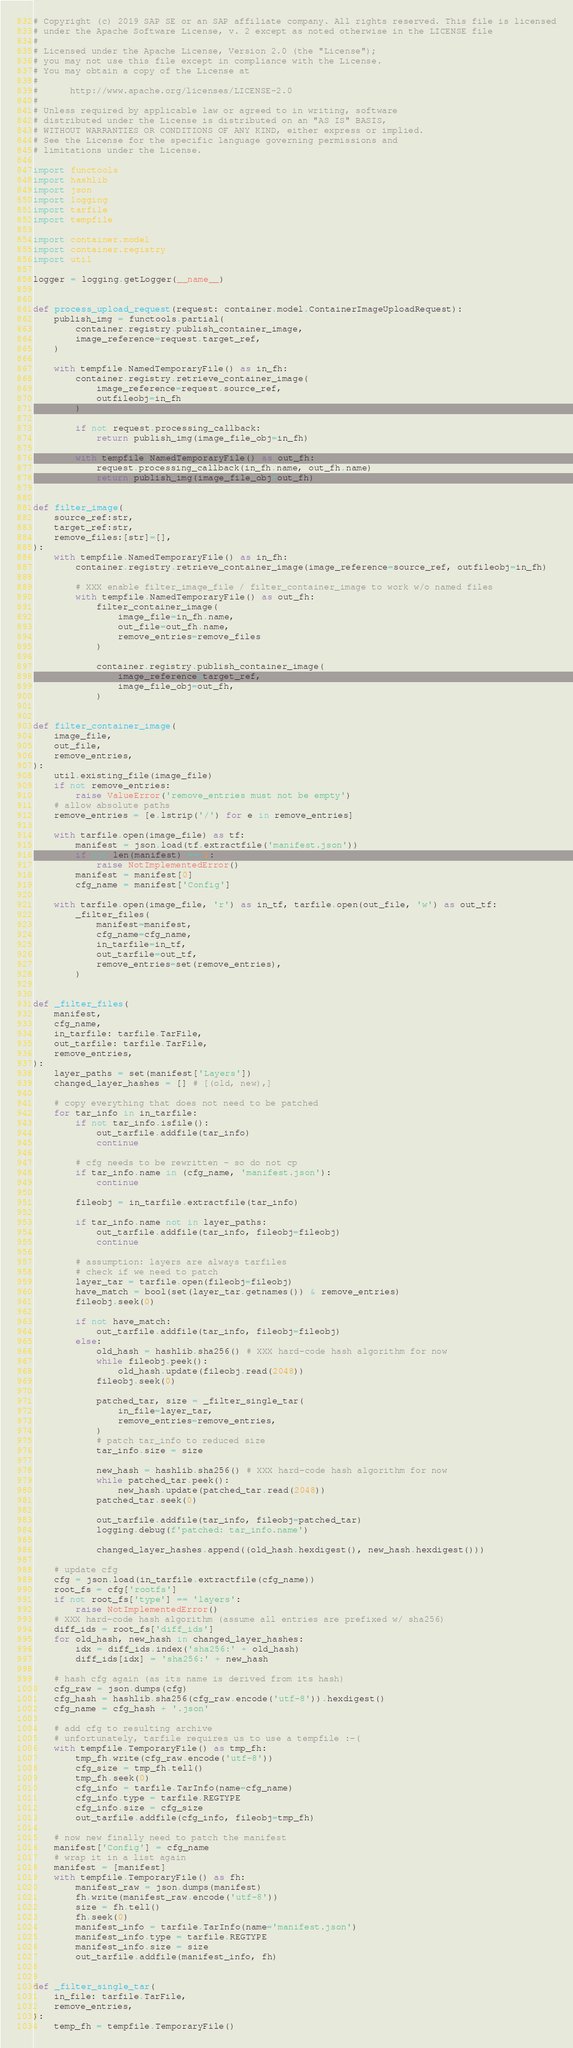<code> <loc_0><loc_0><loc_500><loc_500><_Python_># Copyright (c) 2019 SAP SE or an SAP affiliate company. All rights reserved. This file is licensed
# under the Apache Software License, v. 2 except as noted otherwise in the LICENSE file
#
# Licensed under the Apache License, Version 2.0 (the "License");
# you may not use this file except in compliance with the License.
# You may obtain a copy of the License at
#
#      http://www.apache.org/licenses/LICENSE-2.0
#
# Unless required by applicable law or agreed to in writing, software
# distributed under the License is distributed on an "AS IS" BASIS,
# WITHOUT WARRANTIES OR CONDITIONS OF ANY KIND, either express or implied.
# See the License for the specific language governing permissions and
# limitations under the License.

import functools
import hashlib
import json
import logging
import tarfile
import tempfile

import container.model
import container.registry
import util

logger = logging.getLogger(__name__)


def process_upload_request(request: container.model.ContainerImageUploadRequest):
    publish_img = functools.partial(
        container.registry.publish_container_image,
        image_reference=request.target_ref,
    )

    with tempfile.NamedTemporaryFile() as in_fh:
        container.registry.retrieve_container_image(
            image_reference=request.source_ref,
            outfileobj=in_fh
        )

        if not request.processing_callback:
            return publish_img(image_file_obj=in_fh)

        with tempfile.NamedTemporaryFile() as out_fh:
            request.processing_callback(in_fh.name, out_fh.name)
            return publish_img(image_file_obj=out_fh)


def filter_image(
    source_ref:str,
    target_ref:str,
    remove_files:[str]=[],
):
    with tempfile.NamedTemporaryFile() as in_fh:
        container.registry.retrieve_container_image(image_reference=source_ref, outfileobj=in_fh)

        # XXX enable filter_image_file / filter_container_image to work w/o named files
        with tempfile.NamedTemporaryFile() as out_fh:
            filter_container_image(
                image_file=in_fh.name,
                out_file=out_fh.name,
                remove_entries=remove_files
            )

            container.registry.publish_container_image(
                image_reference=target_ref,
                image_file_obj=out_fh,
            )


def filter_container_image(
    image_file,
    out_file,
    remove_entries,
):
    util.existing_file(image_file)
    if not remove_entries:
        raise ValueError('remove_entries must not be empty')
    # allow absolute paths
    remove_entries = [e.lstrip('/') for e in remove_entries]

    with tarfile.open(image_file) as tf:
        manifest = json.load(tf.extractfile('manifest.json'))
        if not len(manifest) == 1:
            raise NotImplementedError()
        manifest = manifest[0]
        cfg_name = manifest['Config']

    with tarfile.open(image_file, 'r') as in_tf, tarfile.open(out_file, 'w') as out_tf:
        _filter_files(
            manifest=manifest,
            cfg_name=cfg_name,
            in_tarfile=in_tf,
            out_tarfile=out_tf,
            remove_entries=set(remove_entries),
        )


def _filter_files(
    manifest,
    cfg_name,
    in_tarfile: tarfile.TarFile,
    out_tarfile: tarfile.TarFile,
    remove_entries,
):
    layer_paths = set(manifest['Layers'])
    changed_layer_hashes = [] # [(old, new),]

    # copy everything that does not need to be patched
    for tar_info in in_tarfile:
        if not tar_info.isfile():
            out_tarfile.addfile(tar_info)
            continue

        # cfg needs to be rewritten - so do not cp
        if tar_info.name in (cfg_name, 'manifest.json'):
            continue

        fileobj = in_tarfile.extractfile(tar_info)

        if tar_info.name not in layer_paths:
            out_tarfile.addfile(tar_info, fileobj=fileobj)
            continue

        # assumption: layers are always tarfiles
        # check if we need to patch
        layer_tar = tarfile.open(fileobj=fileobj)
        have_match = bool(set(layer_tar.getnames()) & remove_entries)
        fileobj.seek(0)

        if not have_match:
            out_tarfile.addfile(tar_info, fileobj=fileobj)
        else:
            old_hash = hashlib.sha256() # XXX hard-code hash algorithm for now
            while fileobj.peek():
                old_hash.update(fileobj.read(2048))
            fileobj.seek(0)

            patched_tar, size = _filter_single_tar(
                in_file=layer_tar,
                remove_entries=remove_entries,
            )
            # patch tar_info to reduced size
            tar_info.size = size

            new_hash = hashlib.sha256() # XXX hard-code hash algorithm for now
            while patched_tar.peek():
                new_hash.update(patched_tar.read(2048))
            patched_tar.seek(0)

            out_tarfile.addfile(tar_info, fileobj=patched_tar)
            logging.debug(f'patched: tar_info.name')

            changed_layer_hashes.append((old_hash.hexdigest(), new_hash.hexdigest()))

    # update cfg
    cfg = json.load(in_tarfile.extractfile(cfg_name))
    root_fs = cfg['rootfs']
    if not root_fs['type'] == 'layers':
        raise NotImplementedError()
    # XXX hard-code hash algorithm (assume all entries are prefixed w/ sha256)
    diff_ids = root_fs['diff_ids']
    for old_hash, new_hash in changed_layer_hashes:
        idx = diff_ids.index('sha256:' + old_hash)
        diff_ids[idx] = 'sha256:' + new_hash

    # hash cfg again (as its name is derived from its hash)
    cfg_raw = json.dumps(cfg)
    cfg_hash = hashlib.sha256(cfg_raw.encode('utf-8')).hexdigest()
    cfg_name = cfg_hash + '.json'

    # add cfg to resulting archive
    # unfortunately, tarfile requires us to use a tempfile :-(
    with tempfile.TemporaryFile() as tmp_fh:
        tmp_fh.write(cfg_raw.encode('utf-8'))
        cfg_size = tmp_fh.tell()
        tmp_fh.seek(0)
        cfg_info = tarfile.TarInfo(name=cfg_name)
        cfg_info.type = tarfile.REGTYPE
        cfg_info.size = cfg_size
        out_tarfile.addfile(cfg_info, fileobj=tmp_fh)

    # now new finally need to patch the manifest
    manifest['Config'] = cfg_name
    # wrap it in a list again
    manifest = [manifest]
    with tempfile.TemporaryFile() as fh:
        manifest_raw = json.dumps(manifest)
        fh.write(manifest_raw.encode('utf-8'))
        size = fh.tell()
        fh.seek(0)
        manifest_info = tarfile.TarInfo(name='manifest.json')
        manifest_info.type = tarfile.REGTYPE
        manifest_info.size = size
        out_tarfile.addfile(manifest_info, fh)


def _filter_single_tar(
    in_file: tarfile.TarFile,
    remove_entries,
):
    temp_fh = tempfile.TemporaryFile()</code> 